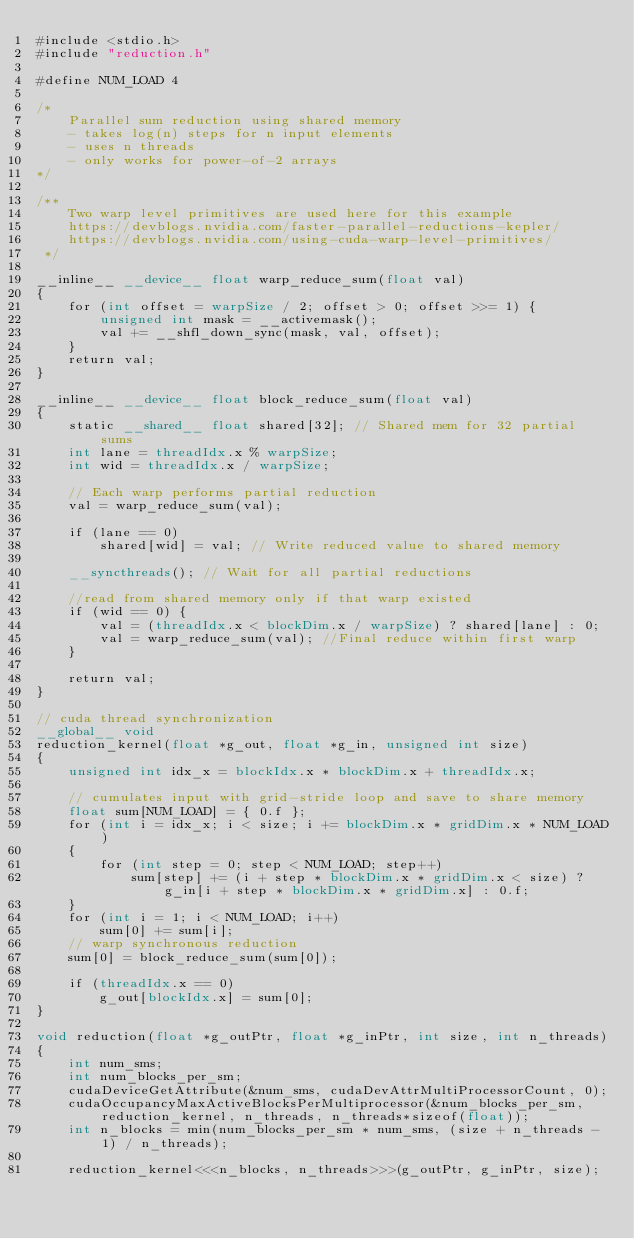Convert code to text. <code><loc_0><loc_0><loc_500><loc_500><_Cuda_>#include <stdio.h>
#include "reduction.h"

#define NUM_LOAD 4

/*
    Parallel sum reduction using shared memory
    - takes log(n) steps for n input elements
    - uses n threads
    - only works for power-of-2 arrays
*/

/**
    Two warp level primitives are used here for this example
    https://devblogs.nvidia.com/faster-parallel-reductions-kepler/
    https://devblogs.nvidia.com/using-cuda-warp-level-primitives/
 */

__inline__ __device__ float warp_reduce_sum(float val)
{
    for (int offset = warpSize / 2; offset > 0; offset >>= 1) {
        unsigned int mask = __activemask();
        val += __shfl_down_sync(mask, val, offset);
    }
    return val;
}

__inline__ __device__ float block_reduce_sum(float val)
{
    static __shared__ float shared[32]; // Shared mem for 32 partial sums
    int lane = threadIdx.x % warpSize;
    int wid = threadIdx.x / warpSize;

    // Each warp performs partial reduction
    val = warp_reduce_sum(val); 

    if (lane == 0)
        shared[wid] = val; // Write reduced value to shared memory

    __syncthreads(); // Wait for all partial reductions

    //read from shared memory only if that warp existed
    if (wid == 0) {
        val = (threadIdx.x < blockDim.x / warpSize) ? shared[lane] : 0;
        val = warp_reduce_sum(val); //Final reduce within first warp
    }

    return val;
}

// cuda thread synchronization
__global__ void
reduction_kernel(float *g_out, float *g_in, unsigned int size)
{
    unsigned int idx_x = blockIdx.x * blockDim.x + threadIdx.x;

    // cumulates input with grid-stride loop and save to share memory
    float sum[NUM_LOAD] = { 0.f };
    for (int i = idx_x; i < size; i += blockDim.x * gridDim.x * NUM_LOAD)
    {
        for (int step = 0; step < NUM_LOAD; step++)
            sum[step] += (i + step * blockDim.x * gridDim.x < size) ? g_in[i + step * blockDim.x * gridDim.x] : 0.f;
    }
    for (int i = 1; i < NUM_LOAD; i++)
        sum[0] += sum[i];
    // warp synchronous reduction
    sum[0] = block_reduce_sum(sum[0]);

    if (threadIdx.x == 0)
        g_out[blockIdx.x] = sum[0];
}

void reduction(float *g_outPtr, float *g_inPtr, int size, int n_threads)
{
    int num_sms;
    int num_blocks_per_sm;
    cudaDeviceGetAttribute(&num_sms, cudaDevAttrMultiProcessorCount, 0);
    cudaOccupancyMaxActiveBlocksPerMultiprocessor(&num_blocks_per_sm, reduction_kernel, n_threads, n_threads*sizeof(float));
    int n_blocks = min(num_blocks_per_sm * num_sms, (size + n_threads - 1) / n_threads);

    reduction_kernel<<<n_blocks, n_threads>>>(g_outPtr, g_inPtr, size);</code> 